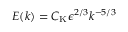<formula> <loc_0><loc_0><loc_500><loc_500>E ( k ) = C _ { K } \epsilon ^ { 2 / 3 } k ^ { - 5 / 3 }</formula> 